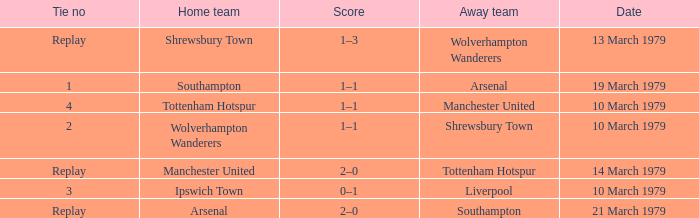What was the score of the tie that had Tottenham Hotspur as the home team? 1–1. 